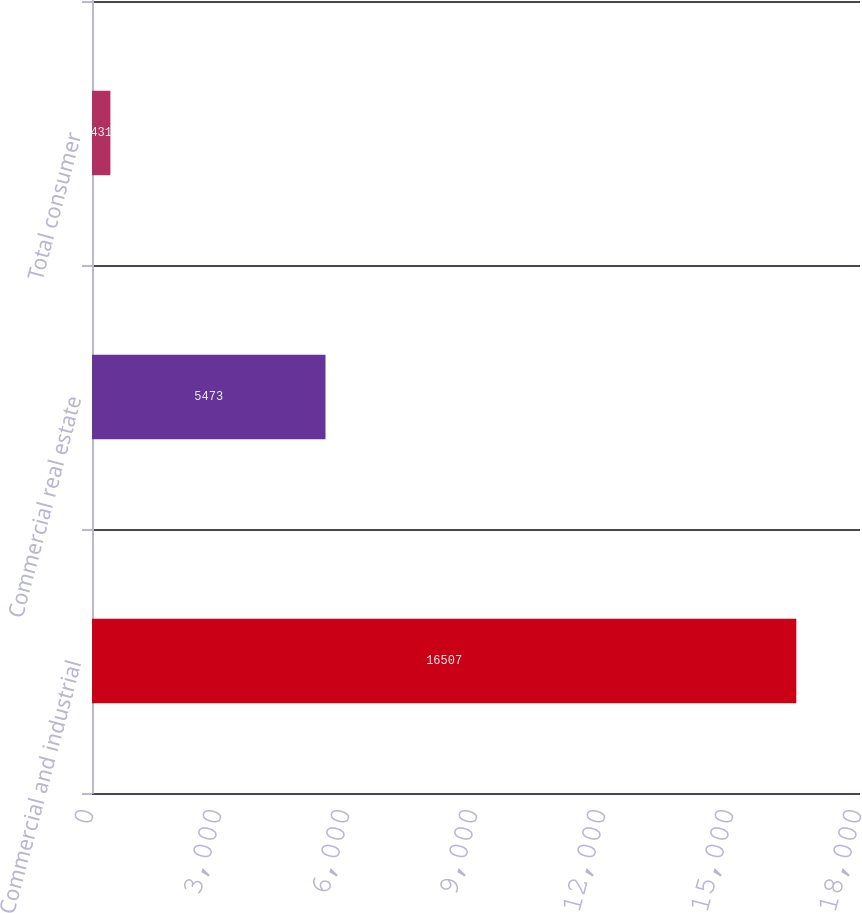Convert chart to OTSL. <chart><loc_0><loc_0><loc_500><loc_500><bar_chart><fcel>Commercial and industrial<fcel>Commercial real estate<fcel>Total consumer<nl><fcel>16507<fcel>5473<fcel>431<nl></chart> 